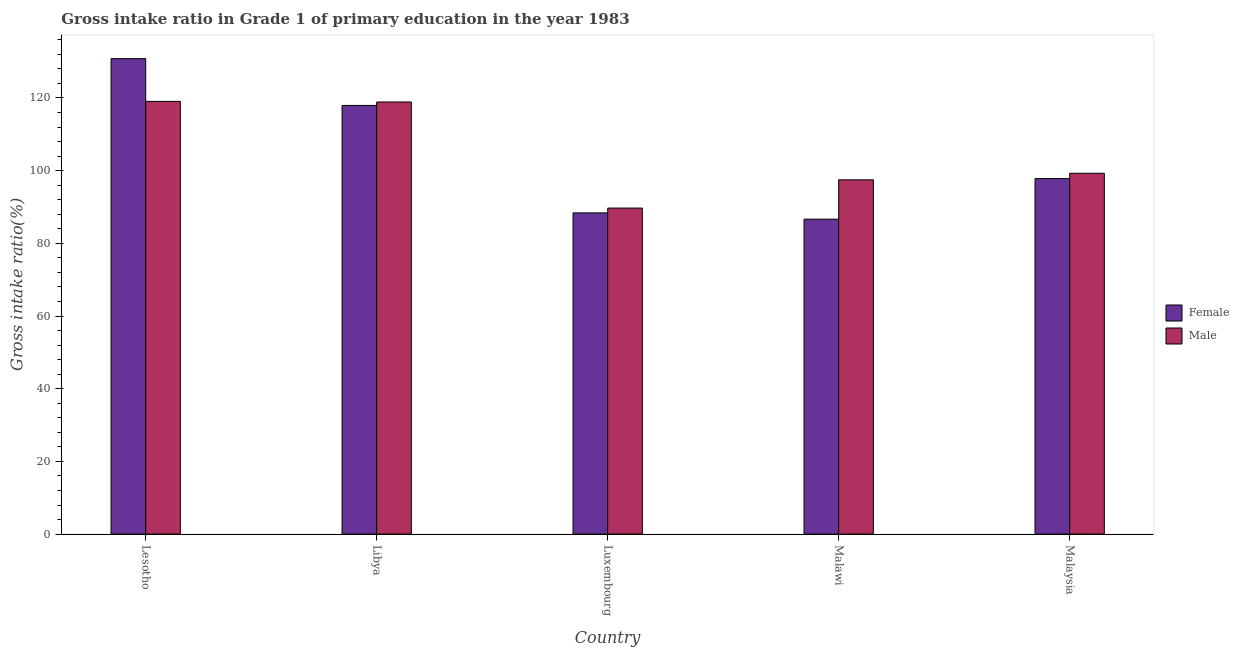How many different coloured bars are there?
Give a very brief answer. 2. Are the number of bars on each tick of the X-axis equal?
Your answer should be compact. Yes. How many bars are there on the 2nd tick from the right?
Your answer should be very brief. 2. What is the label of the 1st group of bars from the left?
Offer a very short reply. Lesotho. In how many cases, is the number of bars for a given country not equal to the number of legend labels?
Your answer should be compact. 0. What is the gross intake ratio(male) in Lesotho?
Keep it short and to the point. 119.07. Across all countries, what is the maximum gross intake ratio(female)?
Your answer should be compact. 130.83. Across all countries, what is the minimum gross intake ratio(male)?
Your answer should be compact. 89.71. In which country was the gross intake ratio(male) maximum?
Provide a short and direct response. Lesotho. In which country was the gross intake ratio(male) minimum?
Ensure brevity in your answer.  Luxembourg. What is the total gross intake ratio(female) in the graph?
Your answer should be very brief. 521.65. What is the difference between the gross intake ratio(male) in Lesotho and that in Malaysia?
Keep it short and to the point. 19.79. What is the difference between the gross intake ratio(female) in Malaysia and the gross intake ratio(male) in Luxembourg?
Provide a short and direct response. 8.11. What is the average gross intake ratio(male) per country?
Give a very brief answer. 104.89. What is the difference between the gross intake ratio(male) and gross intake ratio(female) in Libya?
Your response must be concise. 0.95. What is the ratio of the gross intake ratio(male) in Luxembourg to that in Malaysia?
Your response must be concise. 0.9. Is the gross intake ratio(female) in Lesotho less than that in Luxembourg?
Your answer should be very brief. No. Is the difference between the gross intake ratio(male) in Lesotho and Luxembourg greater than the difference between the gross intake ratio(female) in Lesotho and Luxembourg?
Your answer should be very brief. No. What is the difference between the highest and the second highest gross intake ratio(male)?
Ensure brevity in your answer.  0.17. What is the difference between the highest and the lowest gross intake ratio(male)?
Offer a terse response. 29.36. Is the sum of the gross intake ratio(female) in Lesotho and Malaysia greater than the maximum gross intake ratio(male) across all countries?
Offer a very short reply. Yes. What does the 1st bar from the right in Lesotho represents?
Ensure brevity in your answer.  Male. Are all the bars in the graph horizontal?
Provide a short and direct response. No. How many countries are there in the graph?
Keep it short and to the point. 5. What is the difference between two consecutive major ticks on the Y-axis?
Make the answer very short. 20. Are the values on the major ticks of Y-axis written in scientific E-notation?
Your answer should be compact. No. Does the graph contain any zero values?
Offer a terse response. No. Where does the legend appear in the graph?
Offer a very short reply. Center right. How are the legend labels stacked?
Offer a terse response. Vertical. What is the title of the graph?
Give a very brief answer. Gross intake ratio in Grade 1 of primary education in the year 1983. Does "Not attending school" appear as one of the legend labels in the graph?
Make the answer very short. No. What is the label or title of the Y-axis?
Your answer should be compact. Gross intake ratio(%). What is the Gross intake ratio(%) in Female in Lesotho?
Provide a succinct answer. 130.83. What is the Gross intake ratio(%) of Male in Lesotho?
Your response must be concise. 119.07. What is the Gross intake ratio(%) in Female in Libya?
Provide a succinct answer. 117.95. What is the Gross intake ratio(%) of Male in Libya?
Make the answer very short. 118.9. What is the Gross intake ratio(%) of Female in Luxembourg?
Ensure brevity in your answer.  88.39. What is the Gross intake ratio(%) of Male in Luxembourg?
Ensure brevity in your answer.  89.71. What is the Gross intake ratio(%) in Female in Malawi?
Your answer should be very brief. 86.66. What is the Gross intake ratio(%) in Male in Malawi?
Give a very brief answer. 97.48. What is the Gross intake ratio(%) in Female in Malaysia?
Ensure brevity in your answer.  97.82. What is the Gross intake ratio(%) in Male in Malaysia?
Offer a terse response. 99.28. Across all countries, what is the maximum Gross intake ratio(%) in Female?
Offer a terse response. 130.83. Across all countries, what is the maximum Gross intake ratio(%) of Male?
Give a very brief answer. 119.07. Across all countries, what is the minimum Gross intake ratio(%) of Female?
Ensure brevity in your answer.  86.66. Across all countries, what is the minimum Gross intake ratio(%) of Male?
Your response must be concise. 89.71. What is the total Gross intake ratio(%) in Female in the graph?
Your response must be concise. 521.65. What is the total Gross intake ratio(%) in Male in the graph?
Ensure brevity in your answer.  524.45. What is the difference between the Gross intake ratio(%) in Female in Lesotho and that in Libya?
Your response must be concise. 12.87. What is the difference between the Gross intake ratio(%) of Male in Lesotho and that in Libya?
Give a very brief answer. 0.17. What is the difference between the Gross intake ratio(%) of Female in Lesotho and that in Luxembourg?
Your response must be concise. 42.44. What is the difference between the Gross intake ratio(%) in Male in Lesotho and that in Luxembourg?
Ensure brevity in your answer.  29.36. What is the difference between the Gross intake ratio(%) of Female in Lesotho and that in Malawi?
Offer a terse response. 44.17. What is the difference between the Gross intake ratio(%) in Male in Lesotho and that in Malawi?
Your answer should be very brief. 21.59. What is the difference between the Gross intake ratio(%) in Female in Lesotho and that in Malaysia?
Your answer should be very brief. 33. What is the difference between the Gross intake ratio(%) of Male in Lesotho and that in Malaysia?
Your answer should be very brief. 19.79. What is the difference between the Gross intake ratio(%) of Female in Libya and that in Luxembourg?
Offer a terse response. 29.57. What is the difference between the Gross intake ratio(%) of Male in Libya and that in Luxembourg?
Give a very brief answer. 29.19. What is the difference between the Gross intake ratio(%) of Female in Libya and that in Malawi?
Your answer should be very brief. 31.29. What is the difference between the Gross intake ratio(%) of Male in Libya and that in Malawi?
Your answer should be compact. 21.42. What is the difference between the Gross intake ratio(%) in Female in Libya and that in Malaysia?
Ensure brevity in your answer.  20.13. What is the difference between the Gross intake ratio(%) in Male in Libya and that in Malaysia?
Provide a succinct answer. 19.62. What is the difference between the Gross intake ratio(%) in Female in Luxembourg and that in Malawi?
Ensure brevity in your answer.  1.73. What is the difference between the Gross intake ratio(%) in Male in Luxembourg and that in Malawi?
Offer a very short reply. -7.77. What is the difference between the Gross intake ratio(%) in Female in Luxembourg and that in Malaysia?
Your answer should be very brief. -9.44. What is the difference between the Gross intake ratio(%) of Male in Luxembourg and that in Malaysia?
Ensure brevity in your answer.  -9.57. What is the difference between the Gross intake ratio(%) in Female in Malawi and that in Malaysia?
Ensure brevity in your answer.  -11.16. What is the difference between the Gross intake ratio(%) of Male in Malawi and that in Malaysia?
Your response must be concise. -1.8. What is the difference between the Gross intake ratio(%) in Female in Lesotho and the Gross intake ratio(%) in Male in Libya?
Offer a terse response. 11.92. What is the difference between the Gross intake ratio(%) in Female in Lesotho and the Gross intake ratio(%) in Male in Luxembourg?
Provide a succinct answer. 41.11. What is the difference between the Gross intake ratio(%) of Female in Lesotho and the Gross intake ratio(%) of Male in Malawi?
Offer a terse response. 33.34. What is the difference between the Gross intake ratio(%) of Female in Lesotho and the Gross intake ratio(%) of Male in Malaysia?
Your answer should be compact. 31.54. What is the difference between the Gross intake ratio(%) in Female in Libya and the Gross intake ratio(%) in Male in Luxembourg?
Your response must be concise. 28.24. What is the difference between the Gross intake ratio(%) of Female in Libya and the Gross intake ratio(%) of Male in Malawi?
Your answer should be compact. 20.47. What is the difference between the Gross intake ratio(%) of Female in Libya and the Gross intake ratio(%) of Male in Malaysia?
Make the answer very short. 18.67. What is the difference between the Gross intake ratio(%) of Female in Luxembourg and the Gross intake ratio(%) of Male in Malawi?
Ensure brevity in your answer.  -9.09. What is the difference between the Gross intake ratio(%) of Female in Luxembourg and the Gross intake ratio(%) of Male in Malaysia?
Keep it short and to the point. -10.89. What is the difference between the Gross intake ratio(%) in Female in Malawi and the Gross intake ratio(%) in Male in Malaysia?
Ensure brevity in your answer.  -12.62. What is the average Gross intake ratio(%) in Female per country?
Your response must be concise. 104.33. What is the average Gross intake ratio(%) of Male per country?
Offer a terse response. 104.89. What is the difference between the Gross intake ratio(%) of Female and Gross intake ratio(%) of Male in Lesotho?
Offer a terse response. 11.76. What is the difference between the Gross intake ratio(%) in Female and Gross intake ratio(%) in Male in Libya?
Offer a terse response. -0.95. What is the difference between the Gross intake ratio(%) of Female and Gross intake ratio(%) of Male in Luxembourg?
Your answer should be very brief. -1.32. What is the difference between the Gross intake ratio(%) in Female and Gross intake ratio(%) in Male in Malawi?
Offer a terse response. -10.82. What is the difference between the Gross intake ratio(%) in Female and Gross intake ratio(%) in Male in Malaysia?
Your answer should be very brief. -1.46. What is the ratio of the Gross intake ratio(%) in Female in Lesotho to that in Libya?
Provide a short and direct response. 1.11. What is the ratio of the Gross intake ratio(%) in Male in Lesotho to that in Libya?
Keep it short and to the point. 1. What is the ratio of the Gross intake ratio(%) of Female in Lesotho to that in Luxembourg?
Your answer should be compact. 1.48. What is the ratio of the Gross intake ratio(%) in Male in Lesotho to that in Luxembourg?
Offer a terse response. 1.33. What is the ratio of the Gross intake ratio(%) in Female in Lesotho to that in Malawi?
Provide a short and direct response. 1.51. What is the ratio of the Gross intake ratio(%) of Male in Lesotho to that in Malawi?
Your answer should be compact. 1.22. What is the ratio of the Gross intake ratio(%) in Female in Lesotho to that in Malaysia?
Ensure brevity in your answer.  1.34. What is the ratio of the Gross intake ratio(%) in Male in Lesotho to that in Malaysia?
Your answer should be compact. 1.2. What is the ratio of the Gross intake ratio(%) in Female in Libya to that in Luxembourg?
Offer a terse response. 1.33. What is the ratio of the Gross intake ratio(%) in Male in Libya to that in Luxembourg?
Give a very brief answer. 1.33. What is the ratio of the Gross intake ratio(%) in Female in Libya to that in Malawi?
Your response must be concise. 1.36. What is the ratio of the Gross intake ratio(%) in Male in Libya to that in Malawi?
Make the answer very short. 1.22. What is the ratio of the Gross intake ratio(%) in Female in Libya to that in Malaysia?
Your answer should be very brief. 1.21. What is the ratio of the Gross intake ratio(%) of Male in Libya to that in Malaysia?
Provide a succinct answer. 1.2. What is the ratio of the Gross intake ratio(%) in Female in Luxembourg to that in Malawi?
Give a very brief answer. 1.02. What is the ratio of the Gross intake ratio(%) of Male in Luxembourg to that in Malawi?
Offer a terse response. 0.92. What is the ratio of the Gross intake ratio(%) of Female in Luxembourg to that in Malaysia?
Give a very brief answer. 0.9. What is the ratio of the Gross intake ratio(%) in Male in Luxembourg to that in Malaysia?
Ensure brevity in your answer.  0.9. What is the ratio of the Gross intake ratio(%) of Female in Malawi to that in Malaysia?
Keep it short and to the point. 0.89. What is the ratio of the Gross intake ratio(%) in Male in Malawi to that in Malaysia?
Offer a very short reply. 0.98. What is the difference between the highest and the second highest Gross intake ratio(%) of Female?
Keep it short and to the point. 12.87. What is the difference between the highest and the second highest Gross intake ratio(%) in Male?
Ensure brevity in your answer.  0.17. What is the difference between the highest and the lowest Gross intake ratio(%) of Female?
Your answer should be compact. 44.17. What is the difference between the highest and the lowest Gross intake ratio(%) in Male?
Your answer should be very brief. 29.36. 